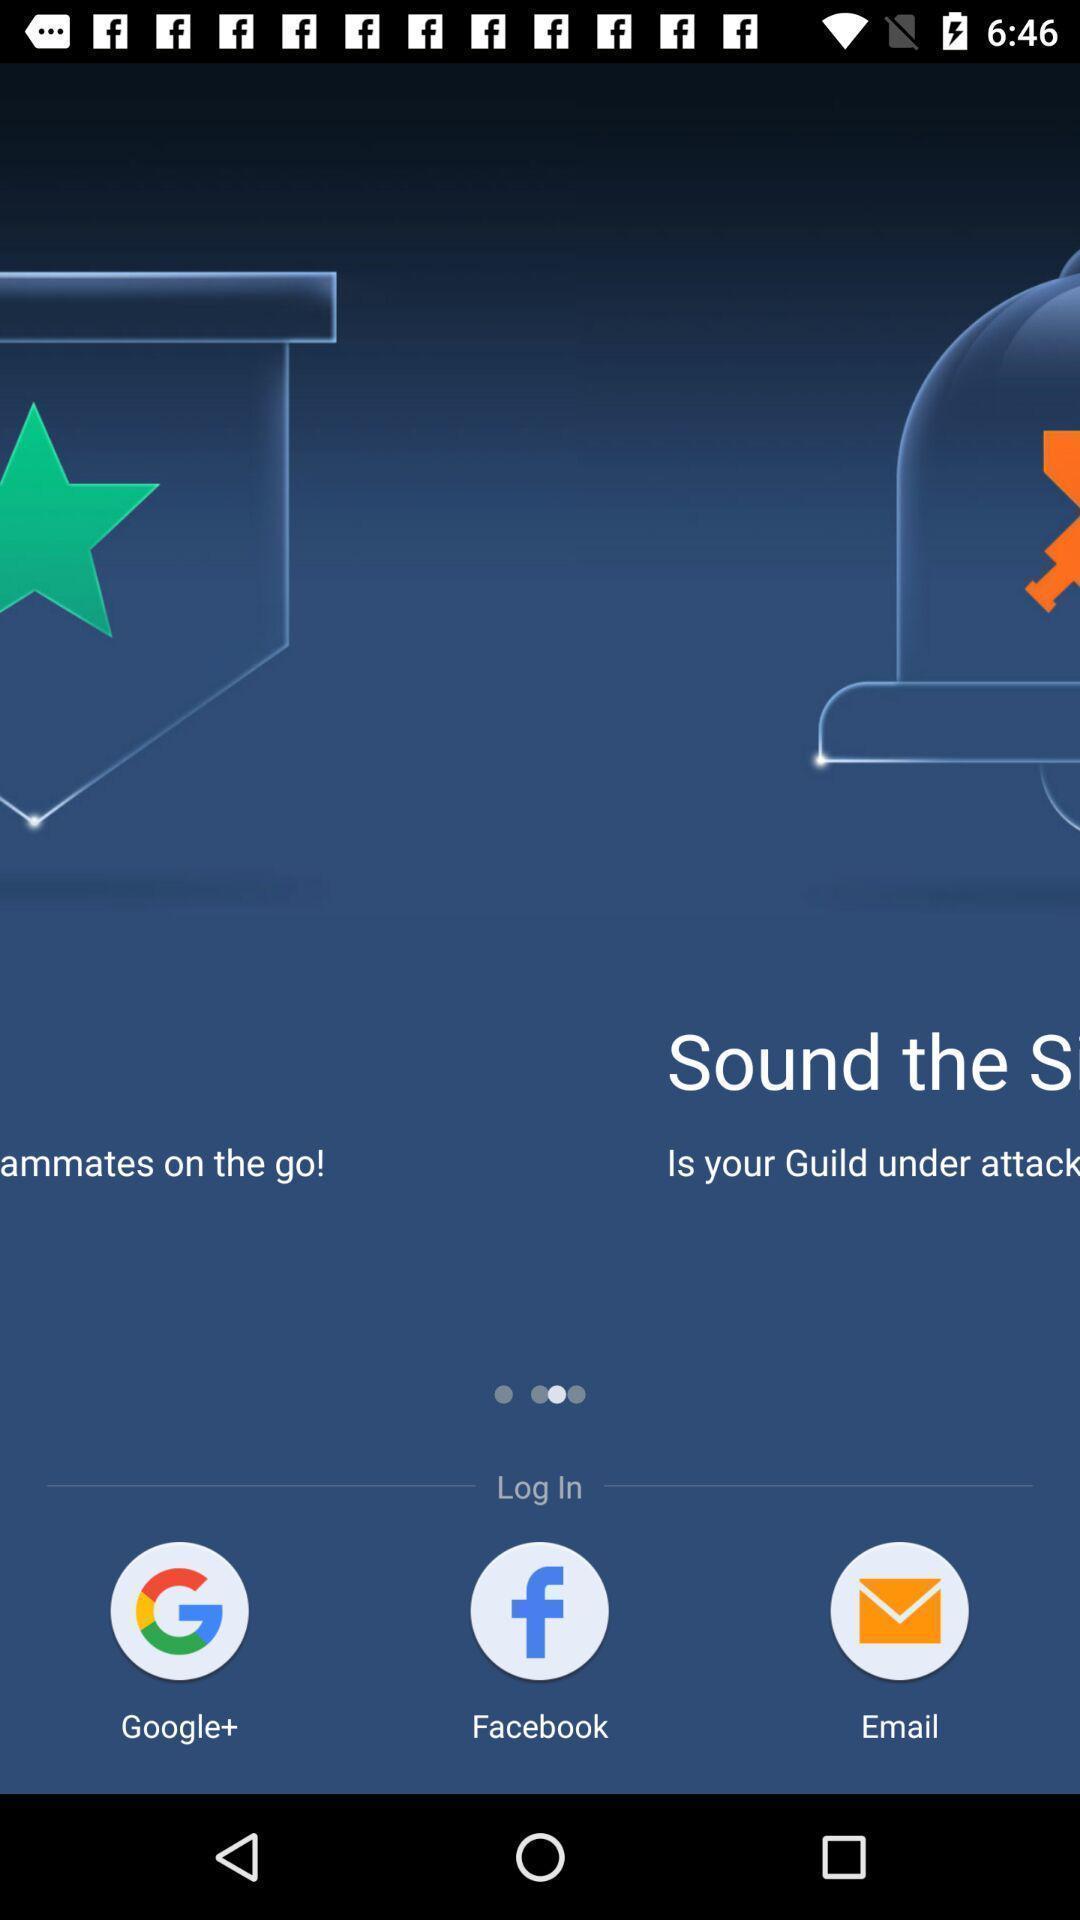Tell me what you see in this picture. Welcome page for an app. 